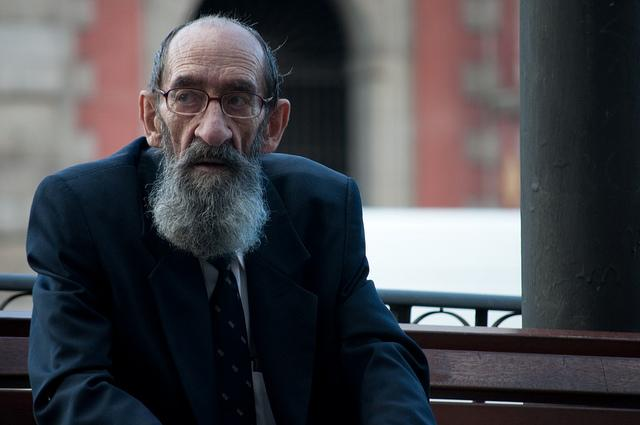What color is the jacket blazer worn by the man with the beard? blue 